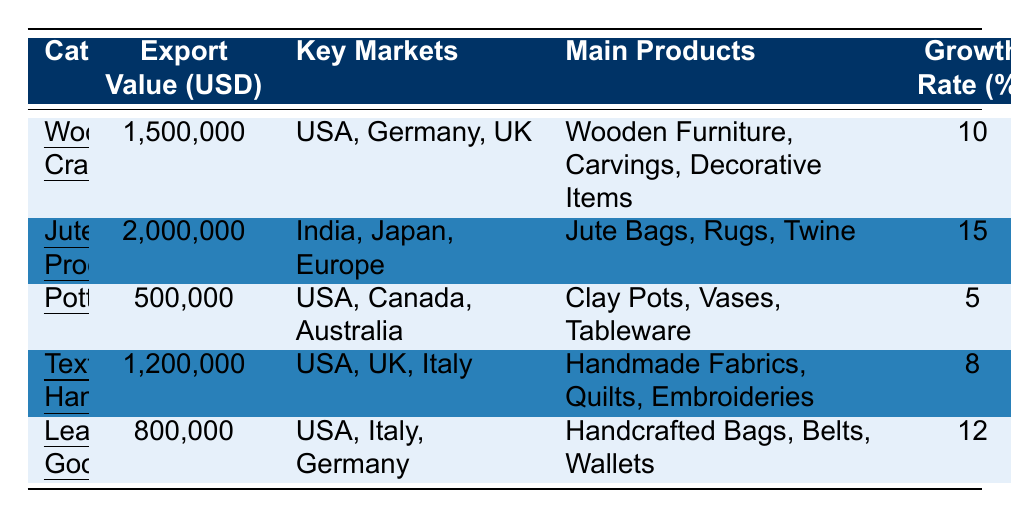What is the export value of Jute Products? The table shows that the export value for Jute Products is listed as 2,000,000 USD.
Answer: 2,000,000 USD Which category has the highest growth rate? The growth rates for each category are: Wooden Crafts (10%), Jute Products (15%), Pottery (5%), Textile Handicrafts (8%), and Leather Goods (12%). Jute Products has the highest at 15%.
Answer: Jute Products How many main products are listed for Leather Goods? The main products for Leather Goods are Handcrafted Bags, Belts, and Wallets, which totals to 3 main products listed.
Answer: 3 What is the total export value of all categories? Adding up the export values: 1,500,000 (Wooden Crafts) + 2,000,000 (Jute Products) + 500,000 (Pottery) + 1,200,000 (Textile Handicrafts) + 800,000 (Leather Goods) equals 6,000,000 USD.
Answer: 6,000,000 USD Is the export value of Textile Handicrafts greater than that of Leather Goods? The export value of Textile Handicrafts is 1,200,000 USD, and for Leather Goods, it is 800,000 USD. Since 1,200,000 is greater than 800,000, the statement is true.
Answer: Yes What is the average export value for the categories listed? The total export value is 6,000,000 USD and there are 5 categories. Dividing 6,000,000 by 5 gives an average of 1,200,000 USD.
Answer: 1,200,000 USD Which key market is common to both Wooden Crafts and Textile Handicrafts? The key markets for Wooden Crafts are USA, Germany, UK, and for Textile Handicrafts, the key markets are USA, UK, Italy. The common market is the USA.
Answer: USA If we compare Jute Products and Leather Goods, which has a higher export value? Jute Products has an export value of 2,000,000 USD and Leather Goods has 800,000 USD. Since 2,000,000 is greater than 800,000, Jute Products has a higher export value.
Answer: Jute Products What is the growth rate difference between Jute Products and Pottery? Jute Products has a growth rate of 15% and Pottery has 5%. The difference is 15% - 5% = 10%.
Answer: 10% 